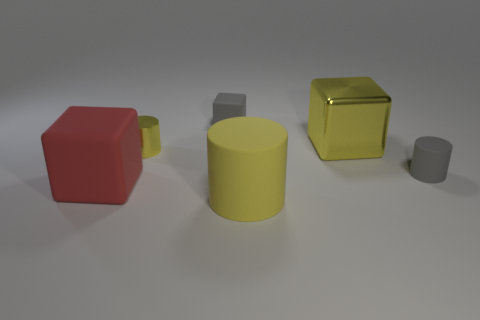Subtract all brown spheres. How many yellow cylinders are left? 2 Add 4 gray rubber cylinders. How many objects exist? 10 Subtract all gray blocks. How many blocks are left? 2 Subtract all red cylinders. Subtract all yellow blocks. How many cylinders are left? 3 Subtract all small cyan shiny cylinders. Subtract all large yellow cubes. How many objects are left? 5 Add 3 small objects. How many small objects are left? 6 Add 5 big red objects. How many big red objects exist? 6 Subtract 0 blue balls. How many objects are left? 6 